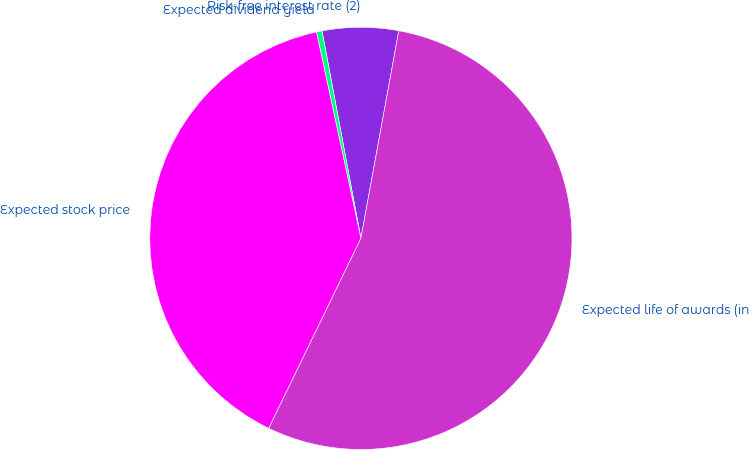Convert chart. <chart><loc_0><loc_0><loc_500><loc_500><pie_chart><fcel>Risk-free interest rate (2)<fcel>Expected dividend yield<fcel>Expected stock price<fcel>Expected life of awards (in<nl><fcel>5.82%<fcel>0.43%<fcel>39.43%<fcel>54.31%<nl></chart> 